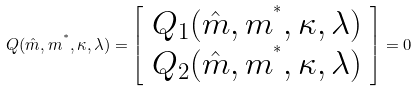<formula> <loc_0><loc_0><loc_500><loc_500>Q ( \hat { m } , m ^ { ^ { * } } , \kappa , \lambda ) = \left [ \begin{array} { c } Q _ { 1 } ( \hat { m } , m ^ { ^ { * } } , \kappa , \lambda ) \\ Q _ { 2 } ( \hat { m } , m ^ { ^ { * } } , \kappa , \lambda ) \\ \end{array} \right ] = 0</formula> 